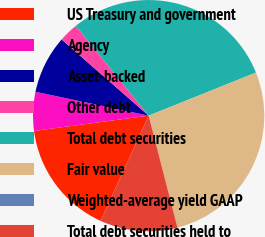Convert chart. <chart><loc_0><loc_0><loc_500><loc_500><pie_chart><fcel>US Treasury and government<fcel>Agency<fcel>Asset-backed<fcel>Other debt<fcel>Total debt securities<fcel>Fair value<fcel>Weighted-average yield GAAP<fcel>Total debt securities held to<nl><fcel>16.07%<fcel>5.42%<fcel>8.13%<fcel>2.71%<fcel>29.77%<fcel>27.06%<fcel>0.01%<fcel>10.83%<nl></chart> 